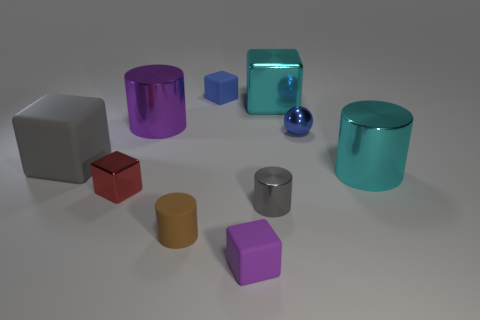What is the size of the object that is the same color as the tiny metal cylinder?
Your answer should be compact. Large. How many small blocks have the same color as the tiny ball?
Offer a very short reply. 1. Do the big matte cube and the tiny metallic cylinder have the same color?
Your answer should be very brief. Yes. What number of other objects are there of the same color as the large matte block?
Offer a very short reply. 1. There is a big matte object; is its color the same as the small cylinder that is right of the small blue cube?
Make the answer very short. Yes. There is a cylinder that is both left of the small purple rubber block and in front of the tiny red shiny cube; what material is it?
Keep it short and to the point. Rubber. Is there a gray matte cube of the same size as the cyan cylinder?
Offer a very short reply. Yes. There is a purple object that is the same size as the blue metallic object; what material is it?
Make the answer very short. Rubber. There is a blue matte cube; what number of big cyan shiny objects are behind it?
Offer a terse response. 0. Do the purple thing that is in front of the small brown matte cylinder and the small gray shiny thing have the same shape?
Your response must be concise. No. 